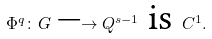<formula> <loc_0><loc_0><loc_500><loc_500>\Phi ^ { q } \colon G \longrightarrow Q ^ { s - 1 } \text { is } C ^ { 1 } .</formula> 